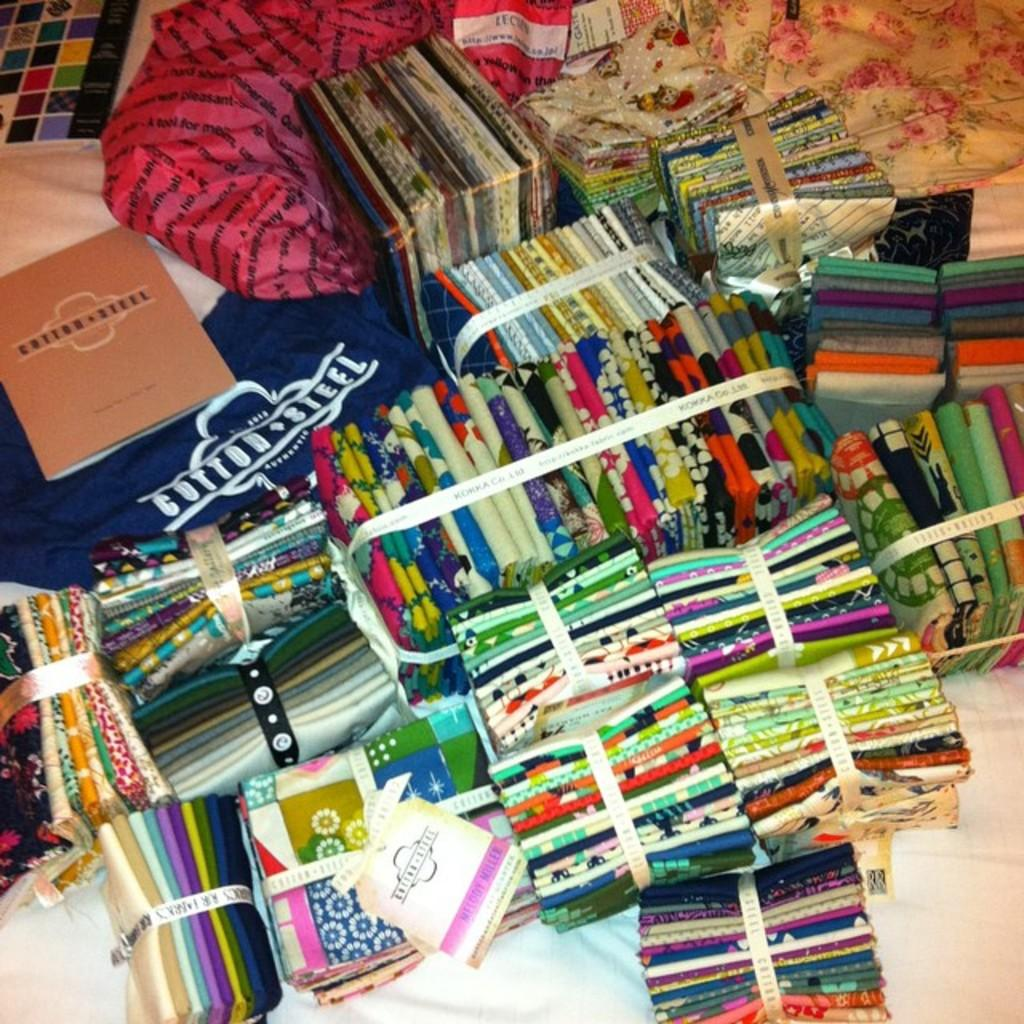Provide a one-sentence caption for the provided image. A bunch of merchandise from the brand name Cotton Steel. 